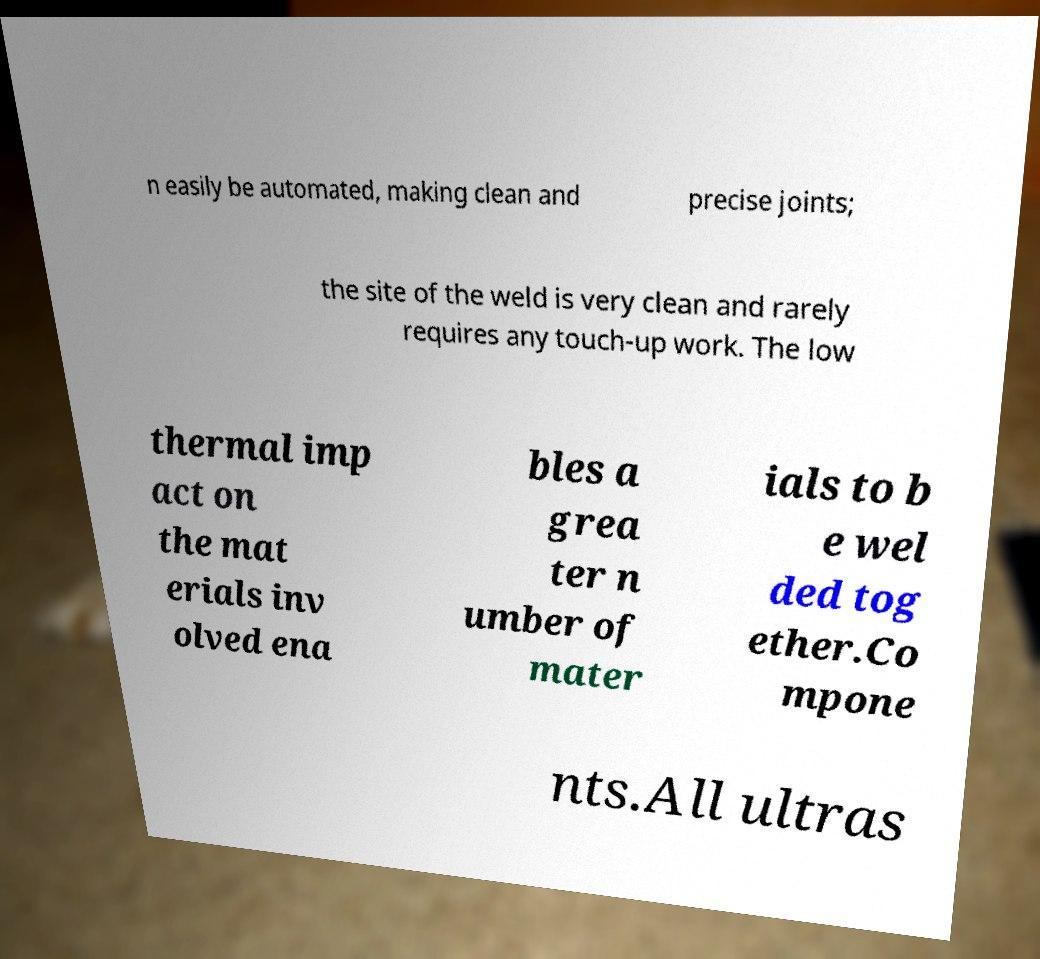Please identify and transcribe the text found in this image. n easily be automated, making clean and precise joints; the site of the weld is very clean and rarely requires any touch-up work. The low thermal imp act on the mat erials inv olved ena bles a grea ter n umber of mater ials to b e wel ded tog ether.Co mpone nts.All ultras 